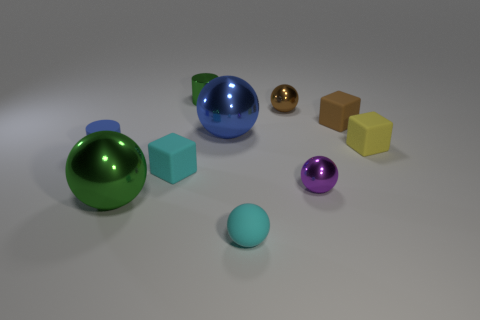Subtract 1 spheres. How many spheres are left? 4 Subtract all purple balls. How many balls are left? 4 Subtract all blue spheres. How many spheres are left? 4 Subtract all red balls. Subtract all purple cylinders. How many balls are left? 5 Subtract all cylinders. How many objects are left? 8 Subtract 1 brown spheres. How many objects are left? 9 Subtract all tiny brown rubber spheres. Subtract all small purple spheres. How many objects are left? 9 Add 8 small metal cylinders. How many small metal cylinders are left? 9 Add 6 large yellow rubber objects. How many large yellow rubber objects exist? 6 